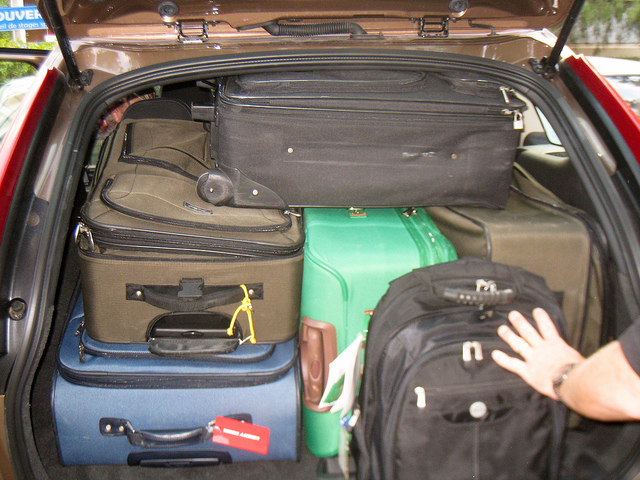<image>What is in the green bottle at the back of the trunk? There is no green bottle at the back of the trunk. However, it can be a suitcase or luggage. What is in the green bottle at the back of the trunk? I don't know what is in the green bottle at the back of the trunk. It can be water, shampoo, or clothing. 